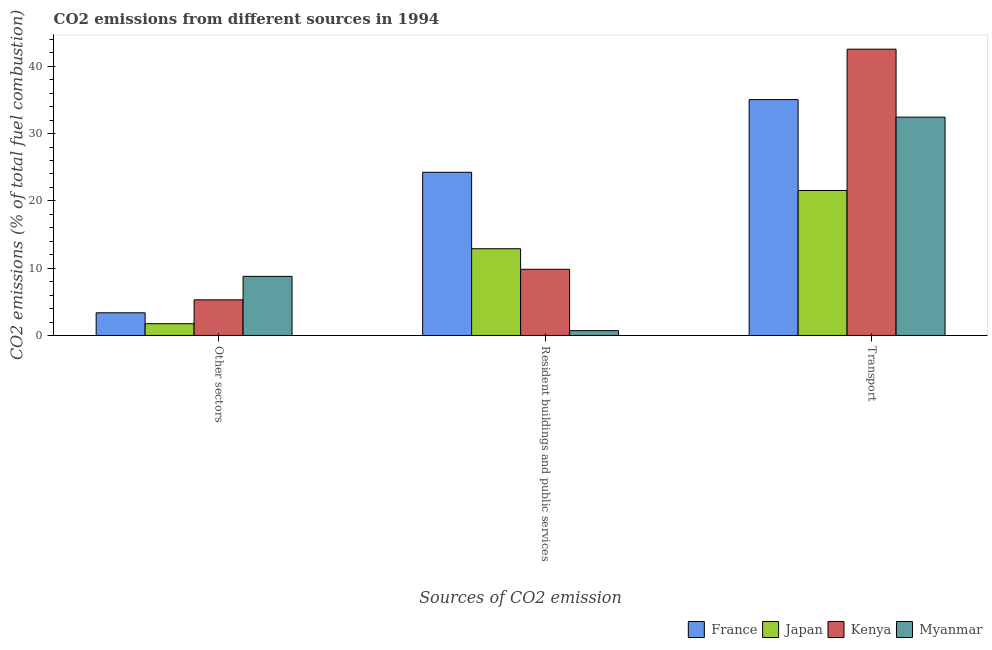How many groups of bars are there?
Your response must be concise. 3. How many bars are there on the 2nd tick from the right?
Your answer should be very brief. 4. What is the label of the 1st group of bars from the left?
Keep it short and to the point. Other sectors. What is the percentage of co2 emissions from transport in Japan?
Give a very brief answer. 21.54. Across all countries, what is the maximum percentage of co2 emissions from other sectors?
Provide a succinct answer. 8.78. Across all countries, what is the minimum percentage of co2 emissions from other sectors?
Provide a succinct answer. 1.75. In which country was the percentage of co2 emissions from resident buildings and public services maximum?
Give a very brief answer. France. What is the total percentage of co2 emissions from transport in the graph?
Give a very brief answer. 131.55. What is the difference between the percentage of co2 emissions from transport in France and that in Kenya?
Make the answer very short. -7.49. What is the difference between the percentage of co2 emissions from other sectors in France and the percentage of co2 emissions from transport in Kenya?
Provide a succinct answer. -39.16. What is the average percentage of co2 emissions from transport per country?
Offer a terse response. 32.89. What is the difference between the percentage of co2 emissions from transport and percentage of co2 emissions from other sectors in Myanmar?
Make the answer very short. 23.66. In how many countries, is the percentage of co2 emissions from transport greater than 8 %?
Give a very brief answer. 4. What is the ratio of the percentage of co2 emissions from other sectors in Kenya to that in Myanmar?
Offer a terse response. 0.6. Is the difference between the percentage of co2 emissions from transport in Kenya and Japan greater than the difference between the percentage of co2 emissions from other sectors in Kenya and Japan?
Provide a short and direct response. Yes. What is the difference between the highest and the second highest percentage of co2 emissions from transport?
Keep it short and to the point. 7.49. What is the difference between the highest and the lowest percentage of co2 emissions from transport?
Offer a very short reply. 20.99. What does the 4th bar from the left in Other sectors represents?
Ensure brevity in your answer.  Myanmar. Is it the case that in every country, the sum of the percentage of co2 emissions from other sectors and percentage of co2 emissions from resident buildings and public services is greater than the percentage of co2 emissions from transport?
Make the answer very short. No. How many bars are there?
Provide a short and direct response. 12. Are all the bars in the graph horizontal?
Offer a terse response. No. What is the difference between two consecutive major ticks on the Y-axis?
Your answer should be compact. 10. Are the values on the major ticks of Y-axis written in scientific E-notation?
Your answer should be very brief. No. Does the graph contain any zero values?
Ensure brevity in your answer.  No. Where does the legend appear in the graph?
Keep it short and to the point. Bottom right. How many legend labels are there?
Ensure brevity in your answer.  4. How are the legend labels stacked?
Give a very brief answer. Horizontal. What is the title of the graph?
Keep it short and to the point. CO2 emissions from different sources in 1994. Does "Bolivia" appear as one of the legend labels in the graph?
Keep it short and to the point. No. What is the label or title of the X-axis?
Your answer should be compact. Sources of CO2 emission. What is the label or title of the Y-axis?
Provide a short and direct response. CO2 emissions (% of total fuel combustion). What is the CO2 emissions (% of total fuel combustion) in France in Other sectors?
Offer a very short reply. 3.37. What is the CO2 emissions (% of total fuel combustion) of Japan in Other sectors?
Your answer should be compact. 1.75. What is the CO2 emissions (% of total fuel combustion) in Kenya in Other sectors?
Provide a short and direct response. 5.29. What is the CO2 emissions (% of total fuel combustion) of Myanmar in Other sectors?
Make the answer very short. 8.78. What is the CO2 emissions (% of total fuel combustion) of France in Resident buildings and public services?
Ensure brevity in your answer.  24.24. What is the CO2 emissions (% of total fuel combustion) in Japan in Resident buildings and public services?
Provide a short and direct response. 12.88. What is the CO2 emissions (% of total fuel combustion) of Kenya in Resident buildings and public services?
Your response must be concise. 9.83. What is the CO2 emissions (% of total fuel combustion) of Myanmar in Resident buildings and public services?
Provide a succinct answer. 0.72. What is the CO2 emissions (% of total fuel combustion) in France in Transport?
Offer a very short reply. 35.04. What is the CO2 emissions (% of total fuel combustion) in Japan in Transport?
Offer a terse response. 21.54. What is the CO2 emissions (% of total fuel combustion) of Kenya in Transport?
Offer a terse response. 42.53. What is the CO2 emissions (% of total fuel combustion) of Myanmar in Transport?
Make the answer very short. 32.44. Across all Sources of CO2 emission, what is the maximum CO2 emissions (% of total fuel combustion) of France?
Offer a very short reply. 35.04. Across all Sources of CO2 emission, what is the maximum CO2 emissions (% of total fuel combustion) in Japan?
Ensure brevity in your answer.  21.54. Across all Sources of CO2 emission, what is the maximum CO2 emissions (% of total fuel combustion) in Kenya?
Make the answer very short. 42.53. Across all Sources of CO2 emission, what is the maximum CO2 emissions (% of total fuel combustion) in Myanmar?
Your answer should be very brief. 32.44. Across all Sources of CO2 emission, what is the minimum CO2 emissions (% of total fuel combustion) of France?
Keep it short and to the point. 3.37. Across all Sources of CO2 emission, what is the minimum CO2 emissions (% of total fuel combustion) of Japan?
Your answer should be compact. 1.75. Across all Sources of CO2 emission, what is the minimum CO2 emissions (% of total fuel combustion) in Kenya?
Make the answer very short. 5.29. Across all Sources of CO2 emission, what is the minimum CO2 emissions (% of total fuel combustion) in Myanmar?
Ensure brevity in your answer.  0.72. What is the total CO2 emissions (% of total fuel combustion) in France in the graph?
Provide a short and direct response. 62.66. What is the total CO2 emissions (% of total fuel combustion) of Japan in the graph?
Your response must be concise. 36.17. What is the total CO2 emissions (% of total fuel combustion) in Kenya in the graph?
Ensure brevity in your answer.  57.66. What is the total CO2 emissions (% of total fuel combustion) in Myanmar in the graph?
Make the answer very short. 41.94. What is the difference between the CO2 emissions (% of total fuel combustion) of France in Other sectors and that in Resident buildings and public services?
Your response must be concise. -20.87. What is the difference between the CO2 emissions (% of total fuel combustion) in Japan in Other sectors and that in Resident buildings and public services?
Offer a very short reply. -11.14. What is the difference between the CO2 emissions (% of total fuel combustion) of Kenya in Other sectors and that in Resident buildings and public services?
Your response must be concise. -4.54. What is the difference between the CO2 emissions (% of total fuel combustion) in Myanmar in Other sectors and that in Resident buildings and public services?
Provide a succinct answer. 8.06. What is the difference between the CO2 emissions (% of total fuel combustion) in France in Other sectors and that in Transport?
Your answer should be very brief. -31.68. What is the difference between the CO2 emissions (% of total fuel combustion) in Japan in Other sectors and that in Transport?
Keep it short and to the point. -19.79. What is the difference between the CO2 emissions (% of total fuel combustion) of Kenya in Other sectors and that in Transport?
Provide a succinct answer. -37.24. What is the difference between the CO2 emissions (% of total fuel combustion) of Myanmar in Other sectors and that in Transport?
Make the answer very short. -23.66. What is the difference between the CO2 emissions (% of total fuel combustion) in France in Resident buildings and public services and that in Transport?
Your answer should be very brief. -10.8. What is the difference between the CO2 emissions (% of total fuel combustion) of Japan in Resident buildings and public services and that in Transport?
Provide a short and direct response. -8.66. What is the difference between the CO2 emissions (% of total fuel combustion) of Kenya in Resident buildings and public services and that in Transport?
Offer a terse response. -32.7. What is the difference between the CO2 emissions (% of total fuel combustion) of Myanmar in Resident buildings and public services and that in Transport?
Provide a succinct answer. -31.72. What is the difference between the CO2 emissions (% of total fuel combustion) in France in Other sectors and the CO2 emissions (% of total fuel combustion) in Japan in Resident buildings and public services?
Make the answer very short. -9.52. What is the difference between the CO2 emissions (% of total fuel combustion) in France in Other sectors and the CO2 emissions (% of total fuel combustion) in Kenya in Resident buildings and public services?
Offer a terse response. -6.46. What is the difference between the CO2 emissions (% of total fuel combustion) in France in Other sectors and the CO2 emissions (% of total fuel combustion) in Myanmar in Resident buildings and public services?
Give a very brief answer. 2.65. What is the difference between the CO2 emissions (% of total fuel combustion) in Japan in Other sectors and the CO2 emissions (% of total fuel combustion) in Kenya in Resident buildings and public services?
Offer a terse response. -8.08. What is the difference between the CO2 emissions (% of total fuel combustion) of Japan in Other sectors and the CO2 emissions (% of total fuel combustion) of Myanmar in Resident buildings and public services?
Offer a terse response. 1.03. What is the difference between the CO2 emissions (% of total fuel combustion) in Kenya in Other sectors and the CO2 emissions (% of total fuel combustion) in Myanmar in Resident buildings and public services?
Keep it short and to the point. 4.58. What is the difference between the CO2 emissions (% of total fuel combustion) in France in Other sectors and the CO2 emissions (% of total fuel combustion) in Japan in Transport?
Offer a very short reply. -18.17. What is the difference between the CO2 emissions (% of total fuel combustion) in France in Other sectors and the CO2 emissions (% of total fuel combustion) in Kenya in Transport?
Offer a terse response. -39.16. What is the difference between the CO2 emissions (% of total fuel combustion) of France in Other sectors and the CO2 emissions (% of total fuel combustion) of Myanmar in Transport?
Your answer should be very brief. -29.07. What is the difference between the CO2 emissions (% of total fuel combustion) of Japan in Other sectors and the CO2 emissions (% of total fuel combustion) of Kenya in Transport?
Ensure brevity in your answer.  -40.78. What is the difference between the CO2 emissions (% of total fuel combustion) of Japan in Other sectors and the CO2 emissions (% of total fuel combustion) of Myanmar in Transport?
Your answer should be compact. -30.69. What is the difference between the CO2 emissions (% of total fuel combustion) of Kenya in Other sectors and the CO2 emissions (% of total fuel combustion) of Myanmar in Transport?
Make the answer very short. -27.14. What is the difference between the CO2 emissions (% of total fuel combustion) of France in Resident buildings and public services and the CO2 emissions (% of total fuel combustion) of Japan in Transport?
Make the answer very short. 2.7. What is the difference between the CO2 emissions (% of total fuel combustion) in France in Resident buildings and public services and the CO2 emissions (% of total fuel combustion) in Kenya in Transport?
Make the answer very short. -18.29. What is the difference between the CO2 emissions (% of total fuel combustion) in France in Resident buildings and public services and the CO2 emissions (% of total fuel combustion) in Myanmar in Transport?
Give a very brief answer. -8.19. What is the difference between the CO2 emissions (% of total fuel combustion) in Japan in Resident buildings and public services and the CO2 emissions (% of total fuel combustion) in Kenya in Transport?
Give a very brief answer. -29.65. What is the difference between the CO2 emissions (% of total fuel combustion) in Japan in Resident buildings and public services and the CO2 emissions (% of total fuel combustion) in Myanmar in Transport?
Provide a succinct answer. -19.55. What is the difference between the CO2 emissions (% of total fuel combustion) of Kenya in Resident buildings and public services and the CO2 emissions (% of total fuel combustion) of Myanmar in Transport?
Offer a very short reply. -22.61. What is the average CO2 emissions (% of total fuel combustion) in France per Sources of CO2 emission?
Your response must be concise. 20.89. What is the average CO2 emissions (% of total fuel combustion) in Japan per Sources of CO2 emission?
Give a very brief answer. 12.06. What is the average CO2 emissions (% of total fuel combustion) in Kenya per Sources of CO2 emission?
Offer a very short reply. 19.22. What is the average CO2 emissions (% of total fuel combustion) in Myanmar per Sources of CO2 emission?
Provide a succinct answer. 13.98. What is the difference between the CO2 emissions (% of total fuel combustion) of France and CO2 emissions (% of total fuel combustion) of Japan in Other sectors?
Your answer should be compact. 1.62. What is the difference between the CO2 emissions (% of total fuel combustion) of France and CO2 emissions (% of total fuel combustion) of Kenya in Other sectors?
Give a very brief answer. -1.92. What is the difference between the CO2 emissions (% of total fuel combustion) of France and CO2 emissions (% of total fuel combustion) of Myanmar in Other sectors?
Offer a very short reply. -5.41. What is the difference between the CO2 emissions (% of total fuel combustion) of Japan and CO2 emissions (% of total fuel combustion) of Kenya in Other sectors?
Offer a very short reply. -3.54. What is the difference between the CO2 emissions (% of total fuel combustion) in Japan and CO2 emissions (% of total fuel combustion) in Myanmar in Other sectors?
Provide a short and direct response. -7.03. What is the difference between the CO2 emissions (% of total fuel combustion) in Kenya and CO2 emissions (% of total fuel combustion) in Myanmar in Other sectors?
Your response must be concise. -3.49. What is the difference between the CO2 emissions (% of total fuel combustion) of France and CO2 emissions (% of total fuel combustion) of Japan in Resident buildings and public services?
Give a very brief answer. 11.36. What is the difference between the CO2 emissions (% of total fuel combustion) of France and CO2 emissions (% of total fuel combustion) of Kenya in Resident buildings and public services?
Ensure brevity in your answer.  14.41. What is the difference between the CO2 emissions (% of total fuel combustion) of France and CO2 emissions (% of total fuel combustion) of Myanmar in Resident buildings and public services?
Provide a short and direct response. 23.53. What is the difference between the CO2 emissions (% of total fuel combustion) in Japan and CO2 emissions (% of total fuel combustion) in Kenya in Resident buildings and public services?
Make the answer very short. 3.05. What is the difference between the CO2 emissions (% of total fuel combustion) of Japan and CO2 emissions (% of total fuel combustion) of Myanmar in Resident buildings and public services?
Your response must be concise. 12.17. What is the difference between the CO2 emissions (% of total fuel combustion) of Kenya and CO2 emissions (% of total fuel combustion) of Myanmar in Resident buildings and public services?
Your answer should be compact. 9.11. What is the difference between the CO2 emissions (% of total fuel combustion) in France and CO2 emissions (% of total fuel combustion) in Japan in Transport?
Your answer should be compact. 13.5. What is the difference between the CO2 emissions (% of total fuel combustion) in France and CO2 emissions (% of total fuel combustion) in Kenya in Transport?
Your response must be concise. -7.49. What is the difference between the CO2 emissions (% of total fuel combustion) in France and CO2 emissions (% of total fuel combustion) in Myanmar in Transport?
Offer a very short reply. 2.61. What is the difference between the CO2 emissions (% of total fuel combustion) of Japan and CO2 emissions (% of total fuel combustion) of Kenya in Transport?
Make the answer very short. -20.99. What is the difference between the CO2 emissions (% of total fuel combustion) in Japan and CO2 emissions (% of total fuel combustion) in Myanmar in Transport?
Keep it short and to the point. -10.9. What is the difference between the CO2 emissions (% of total fuel combustion) in Kenya and CO2 emissions (% of total fuel combustion) in Myanmar in Transport?
Make the answer very short. 10.1. What is the ratio of the CO2 emissions (% of total fuel combustion) in France in Other sectors to that in Resident buildings and public services?
Make the answer very short. 0.14. What is the ratio of the CO2 emissions (% of total fuel combustion) of Japan in Other sectors to that in Resident buildings and public services?
Make the answer very short. 0.14. What is the ratio of the CO2 emissions (% of total fuel combustion) in Kenya in Other sectors to that in Resident buildings and public services?
Make the answer very short. 0.54. What is the ratio of the CO2 emissions (% of total fuel combustion) of Myanmar in Other sectors to that in Resident buildings and public services?
Your answer should be compact. 12.25. What is the ratio of the CO2 emissions (% of total fuel combustion) of France in Other sectors to that in Transport?
Your answer should be very brief. 0.1. What is the ratio of the CO2 emissions (% of total fuel combustion) of Japan in Other sectors to that in Transport?
Your answer should be very brief. 0.08. What is the ratio of the CO2 emissions (% of total fuel combustion) in Kenya in Other sectors to that in Transport?
Offer a very short reply. 0.12. What is the ratio of the CO2 emissions (% of total fuel combustion) of Myanmar in Other sectors to that in Transport?
Offer a terse response. 0.27. What is the ratio of the CO2 emissions (% of total fuel combustion) in France in Resident buildings and public services to that in Transport?
Your answer should be very brief. 0.69. What is the ratio of the CO2 emissions (% of total fuel combustion) in Japan in Resident buildings and public services to that in Transport?
Your answer should be compact. 0.6. What is the ratio of the CO2 emissions (% of total fuel combustion) in Kenya in Resident buildings and public services to that in Transport?
Offer a terse response. 0.23. What is the ratio of the CO2 emissions (% of total fuel combustion) in Myanmar in Resident buildings and public services to that in Transport?
Your answer should be compact. 0.02. What is the difference between the highest and the second highest CO2 emissions (% of total fuel combustion) in France?
Provide a short and direct response. 10.8. What is the difference between the highest and the second highest CO2 emissions (% of total fuel combustion) of Japan?
Your response must be concise. 8.66. What is the difference between the highest and the second highest CO2 emissions (% of total fuel combustion) of Kenya?
Ensure brevity in your answer.  32.7. What is the difference between the highest and the second highest CO2 emissions (% of total fuel combustion) of Myanmar?
Give a very brief answer. 23.66. What is the difference between the highest and the lowest CO2 emissions (% of total fuel combustion) of France?
Offer a terse response. 31.68. What is the difference between the highest and the lowest CO2 emissions (% of total fuel combustion) in Japan?
Your answer should be very brief. 19.79. What is the difference between the highest and the lowest CO2 emissions (% of total fuel combustion) in Kenya?
Give a very brief answer. 37.24. What is the difference between the highest and the lowest CO2 emissions (% of total fuel combustion) of Myanmar?
Provide a short and direct response. 31.72. 